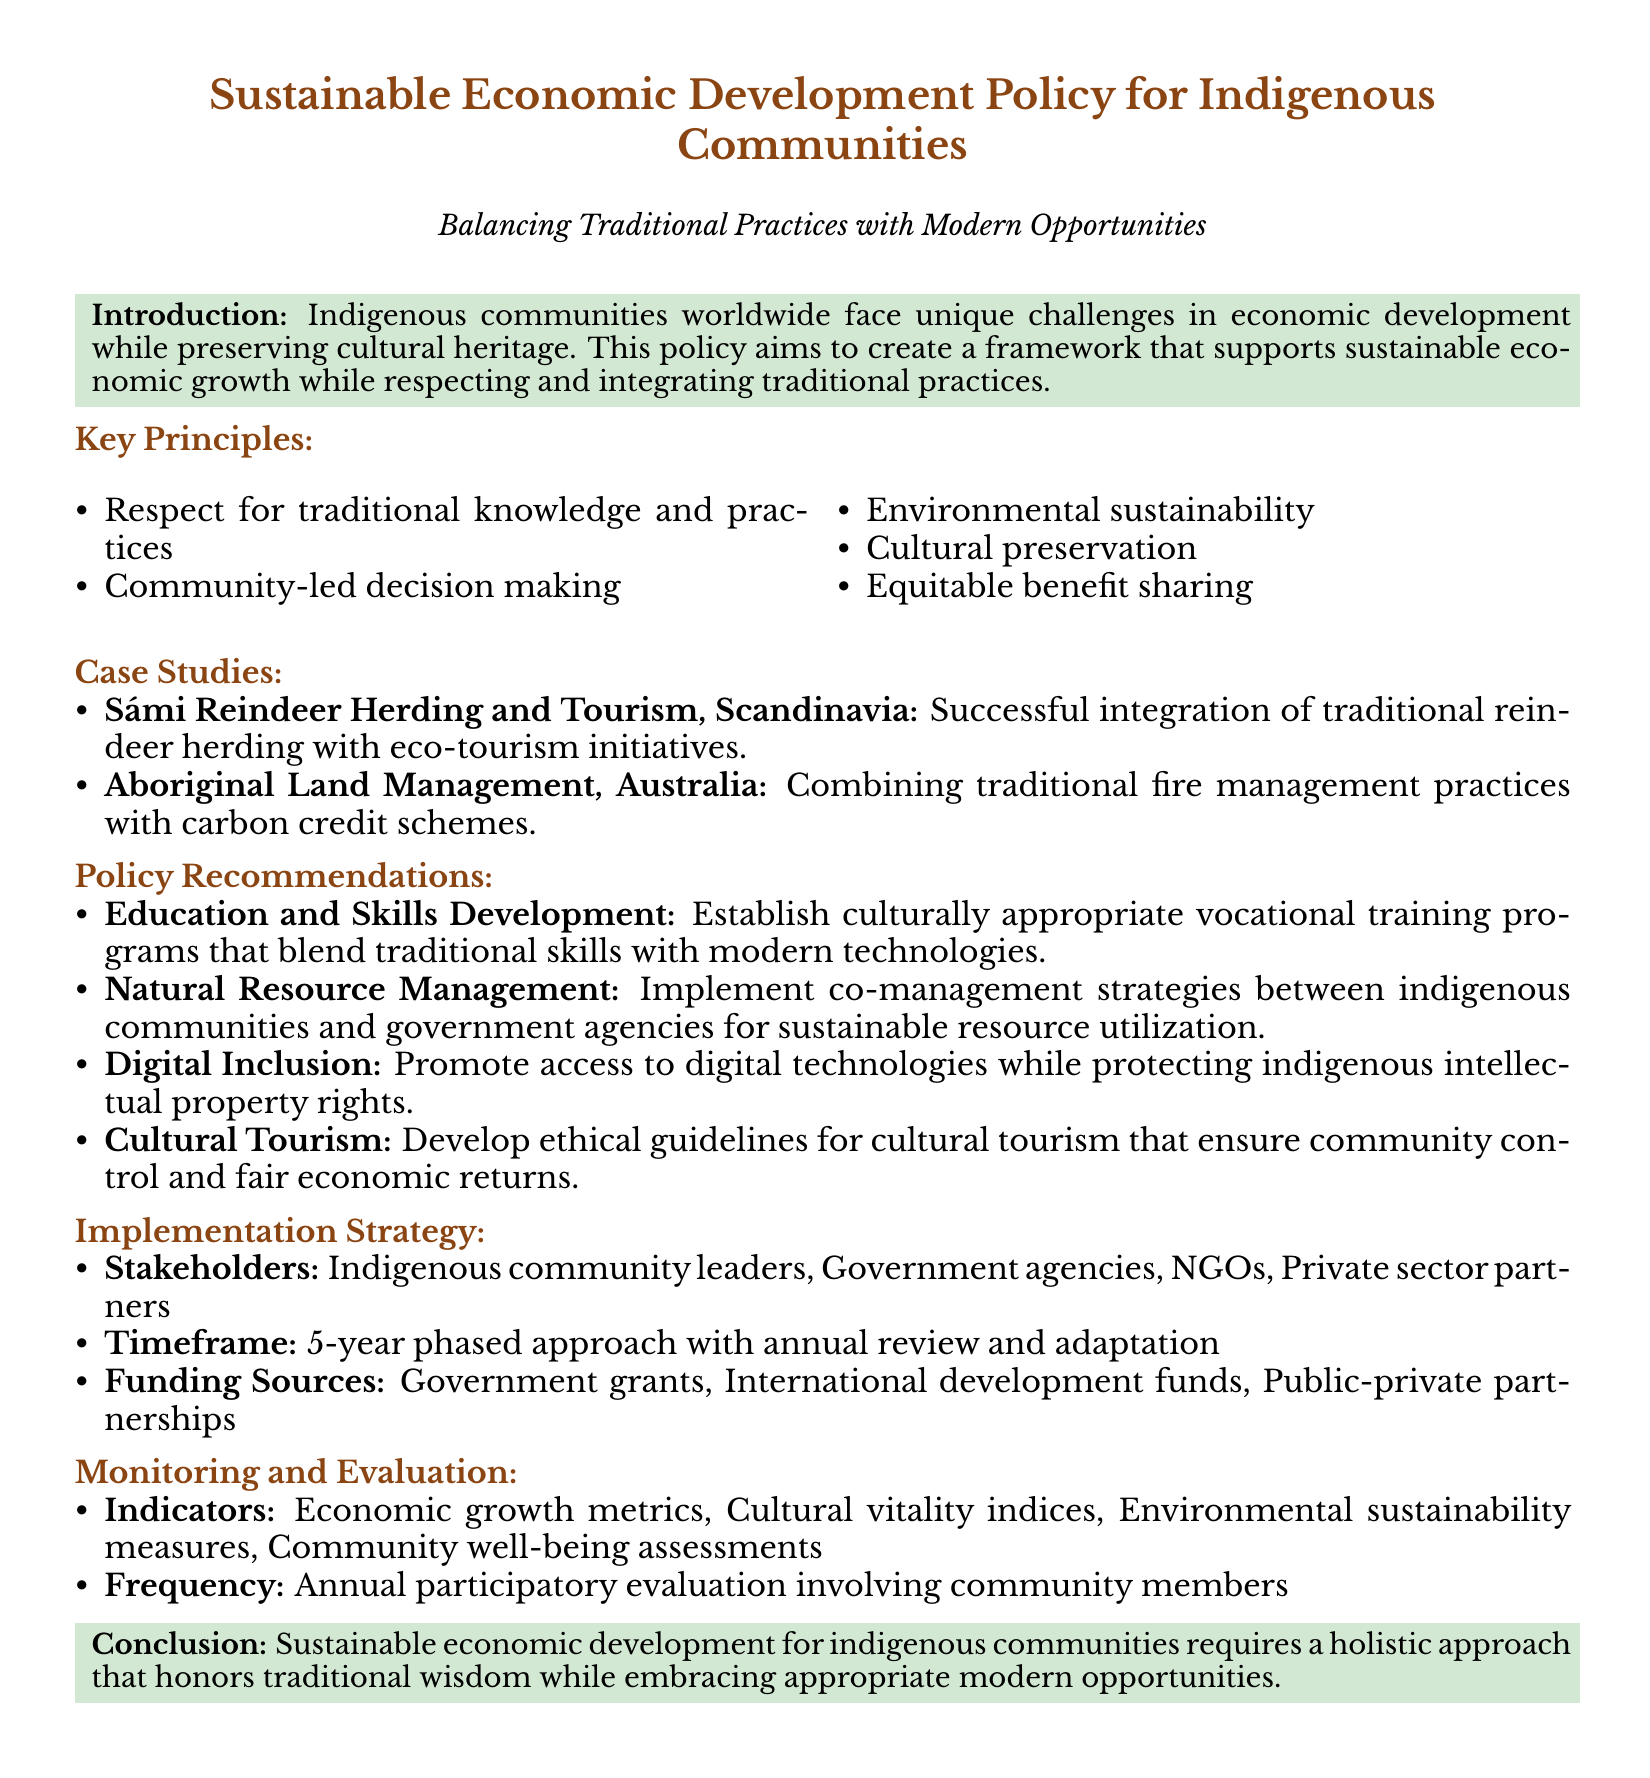what is the primary aim of the policy? The primary aim of the policy is to create a framework that supports sustainable economic growth while respecting and integrating traditional practices.
Answer: to create a framework that supports sustainable economic growth while respecting and integrating traditional practices which community-led case study is mentioned in the document? The case study illustrating community-led initiatives is the Sámi Reindeer Herding and Tourism in Scandinavia.
Answer: Sámi Reindeer Herding and Tourism what are the key principles outlined in the document? The key principles include respect for traditional knowledge and practices, community-led decision making, environmental sustainability, cultural preservation, and equitable benefit sharing.
Answer: respect for traditional knowledge and practices, community-led decision making, environmental sustainability, cultural preservation, equitable benefit sharing how long is the proposed timeframe for implementation? The proposed timeframe for implementation is a 5-year phased approach.
Answer: 5-year what is one of the recommended areas for policy implementation? One recommended area for policy implementation is education and skills development.
Answer: education and skills development who are the key stakeholders involved in implementation? The key stakeholders involved in implementation include indigenous community leaders, government agencies, NGOs, and private sector partners.
Answer: indigenous community leaders, government agencies, NGOs, private sector partners what type of evaluation is suggested in the monitoring section? The suggested evaluation type is annual participatory evaluation involving community members.
Answer: annual participatory evaluation what does the conclusion emphasize? The conclusion emphasizes that sustainable economic development requires a holistic approach.
Answer: a holistic approach what should be promoted to enhance digital inclusion? Digital inclusion should promote access to digital technologies while protecting indigenous intellectual property rights.
Answer: access to digital technologies while protecting indigenous intellectual property rights 